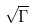<formula> <loc_0><loc_0><loc_500><loc_500>\sqrt { \Gamma }</formula> 